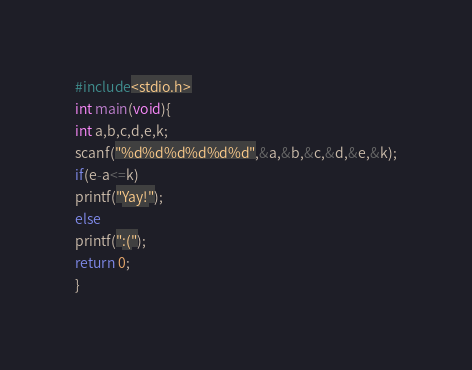Convert code to text. <code><loc_0><loc_0><loc_500><loc_500><_C_>#include<stdio.h>
int main(void){
int a,b,c,d,e,k;
scanf("%d%d%d%d%d%d",&a,&b,&c,&d,&e,&k);
if(e-a<=k)
printf("Yay!");
else
printf(":(");
return 0;
}</code> 